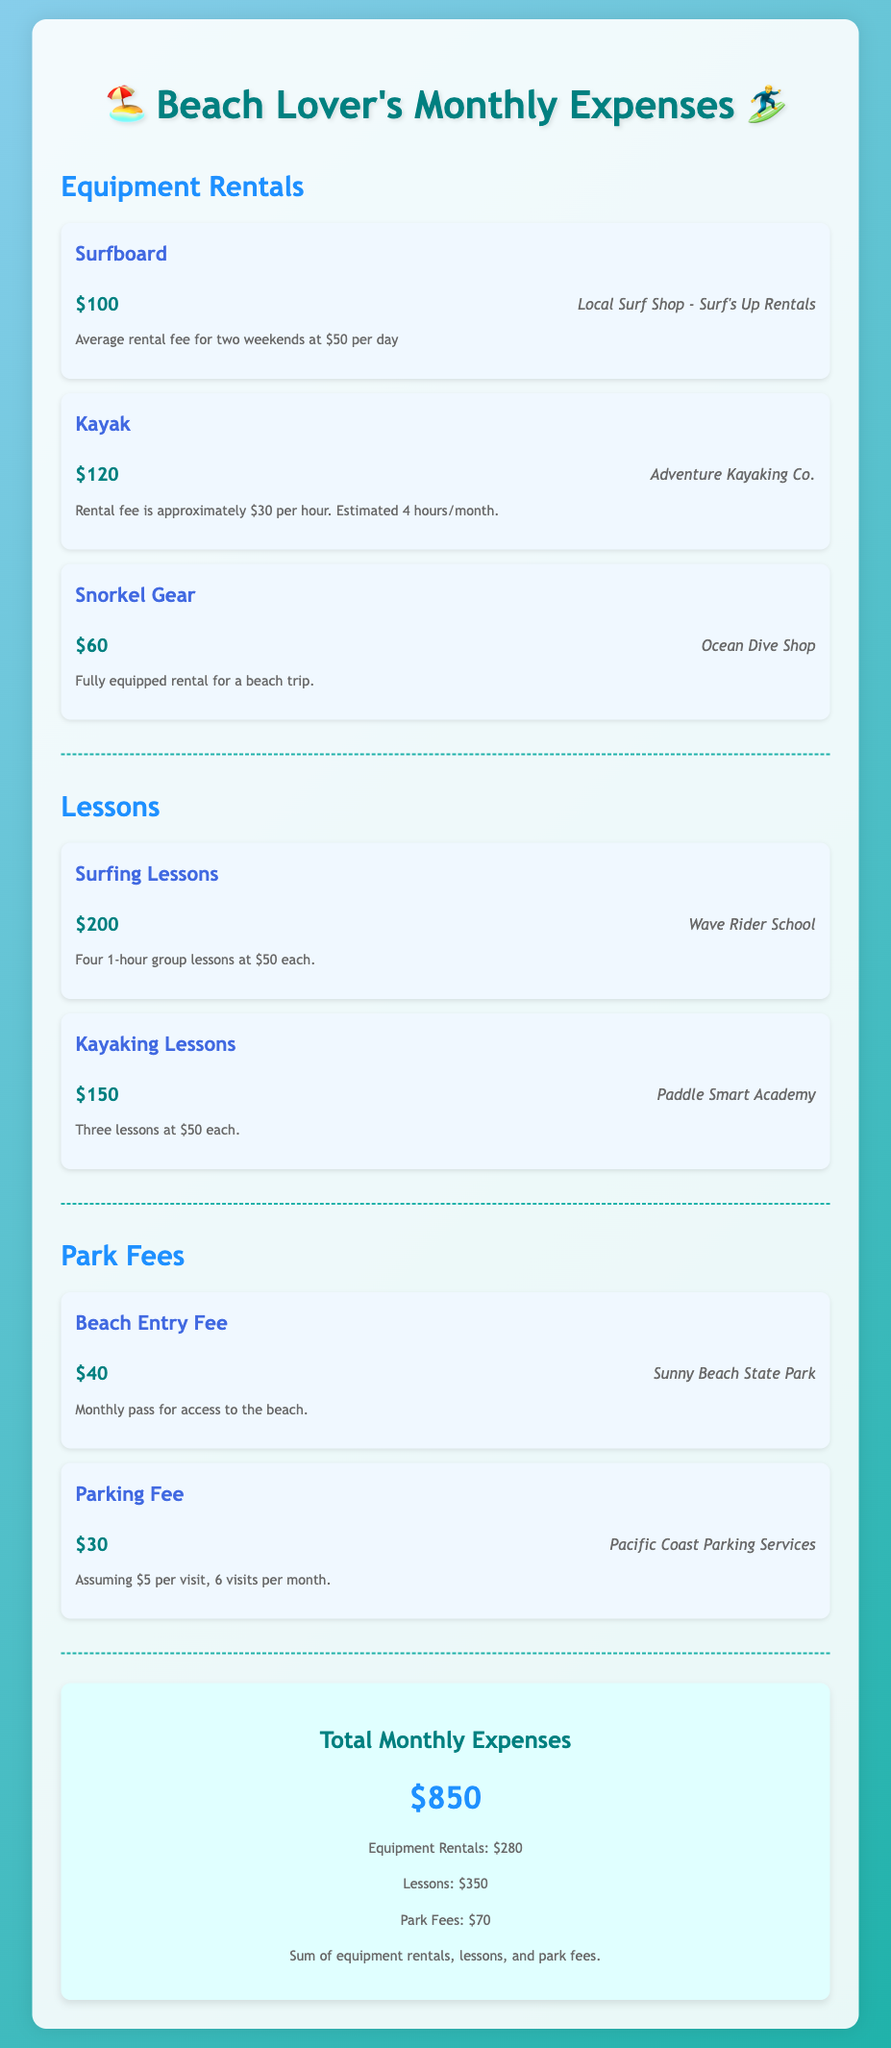What is the total monthly expense? The total monthly expense is provided in the document, which sums all categories of expenses.
Answer: $850 How much is spent on surfboard rentals? The document indicates the rental fee specifically for surfing equipment.
Answer: $100 What is the cost of kayaking lessons? The cost associated with kayaking lessons is listed directly under the lessons category.
Answer: $150 How many hours of kayak rental are estimated per month? The estimate for kayak rental hours is mentioned in the details of the kayak expense item.
Answer: 4 hours What is the source for surfboard rentals? The document specifies the name of the shop that provides surfboard rentals.
Answer: Surf's Up Rentals What is the total for equipment rentals? The total expense for all equipment rentals is calculated from the individual rental costs.
Answer: $280 How many surfing lessons are included in the total cost? The number of surfing lessons is detailed in the surf lessons expense item.
Answer: 4 lessons What are the park fee categories included? The document outlines specific park fees for different access types, identifying them clearly.
Answer: Beach Entry Fee and Parking Fee What is the cost per visit for parking? The document breaks down the parking fee per visit, which leads to a monthly estimate.
Answer: $5 per visit 